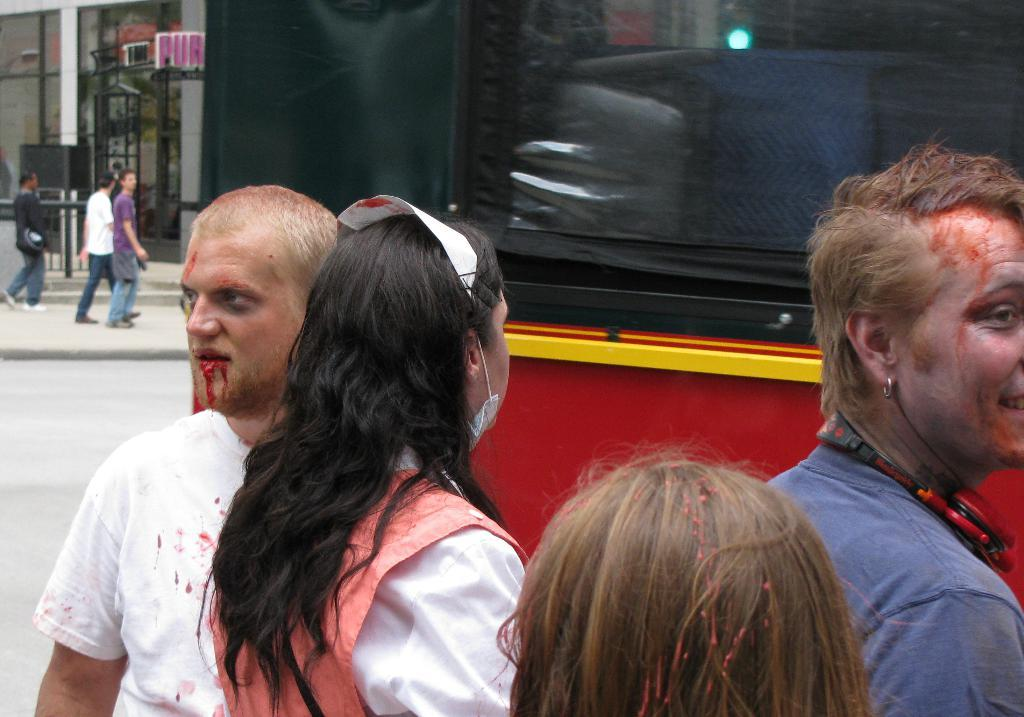How many people are in the image? There is a group of people in the image, but the exact number cannot be determined from the provided facts. What type of vehicle is in the image? The facts do not specify the type of vehicle in the image. What is the building in the image used for? The facts do not provide information about the purpose or function of the building in the image. What is the weight of the beast that is attacking the group of people in the image? There is no beast present in the image, and therefore no such attack can be observed. 